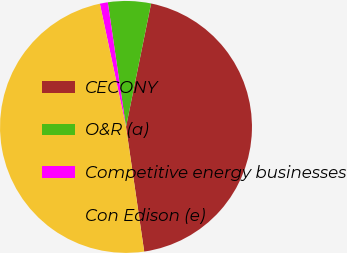Convert chart. <chart><loc_0><loc_0><loc_500><loc_500><pie_chart><fcel>CECONY<fcel>O&R (a)<fcel>Competitive energy businesses<fcel>Con Edison (e)<nl><fcel>44.5%<fcel>5.5%<fcel>1.02%<fcel>48.98%<nl></chart> 